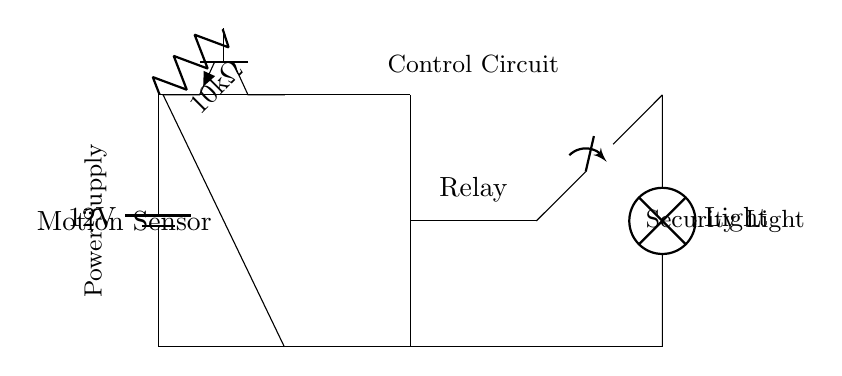What is the voltage of this circuit? The voltage is twelve volts, which is the potential difference indicated by the battery symbol in the circuit diagram.
Answer: twelve volts What component senses motion? The motion sensor is the component that is labeled in the circuit diagram, which detects movement to activate the relay.
Answer: motion sensor What is the resistance value of the resistor? The resistance value is ten thousand ohms, as indicated next to the resistor in the circuit diagram.
Answer: ten thousand ohms Which component controls the light activation? The relay is the component that activates the light based on the input from the motion sensor, as shown in the circuit connections.
Answer: relay How does the circuit receive power? The circuit receives power from a twelve-volt battery, which is connected at the top of the circuit diagram.
Answer: battery What happens when motion is detected? When motion is detected, the motion sensor activates the relay, which then closes the switch to turn on the security light.
Answer: turns on the security light What type of circuit is this? This is a control circuit designed specifically for activating a light based on motion detection for security purposes.
Answer: control circuit 